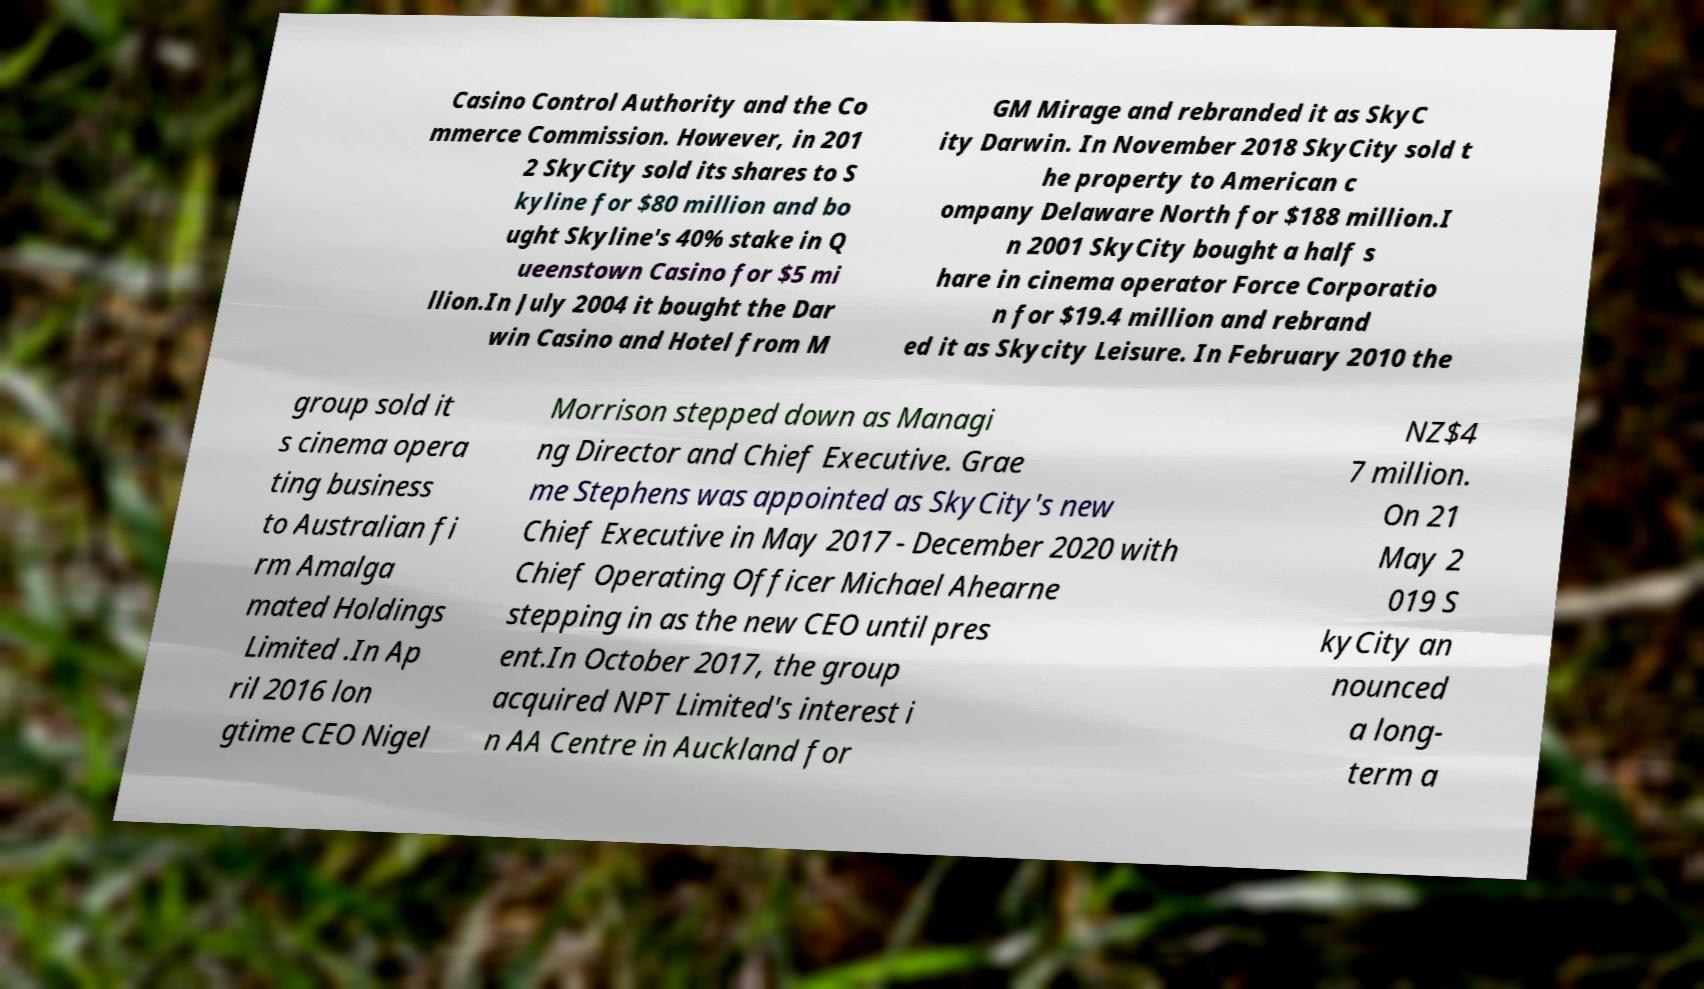Can you accurately transcribe the text from the provided image for me? Casino Control Authority and the Co mmerce Commission. However, in 201 2 SkyCity sold its shares to S kyline for $80 million and bo ught Skyline's 40% stake in Q ueenstown Casino for $5 mi llion.In July 2004 it bought the Dar win Casino and Hotel from M GM Mirage and rebranded it as SkyC ity Darwin. In November 2018 SkyCity sold t he property to American c ompany Delaware North for $188 million.I n 2001 SkyCity bought a half s hare in cinema operator Force Corporatio n for $19.4 million and rebrand ed it as Skycity Leisure. In February 2010 the group sold it s cinema opera ting business to Australian fi rm Amalga mated Holdings Limited .In Ap ril 2016 lon gtime CEO Nigel Morrison stepped down as Managi ng Director and Chief Executive. Grae me Stephens was appointed as SkyCity's new Chief Executive in May 2017 - December 2020 with Chief Operating Officer Michael Ahearne stepping in as the new CEO until pres ent.In October 2017, the group acquired NPT Limited's interest i n AA Centre in Auckland for NZ$4 7 million. On 21 May 2 019 S kyCity an nounced a long- term a 